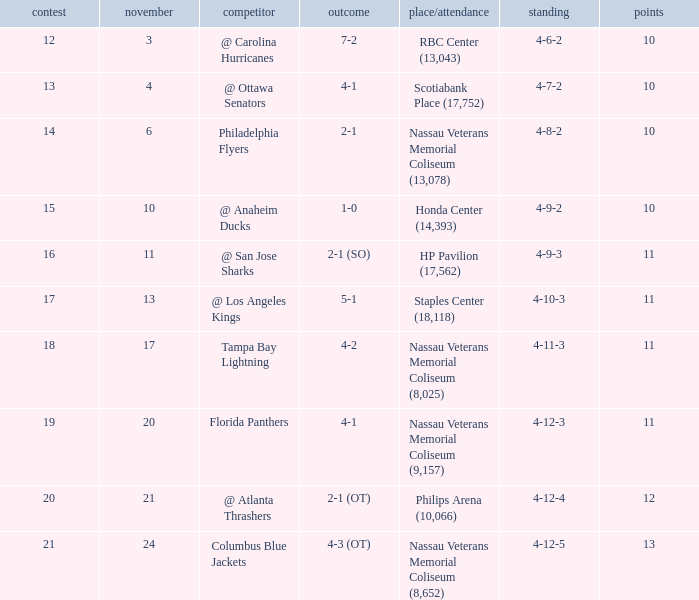What is the highest amount of points? 13.0. 